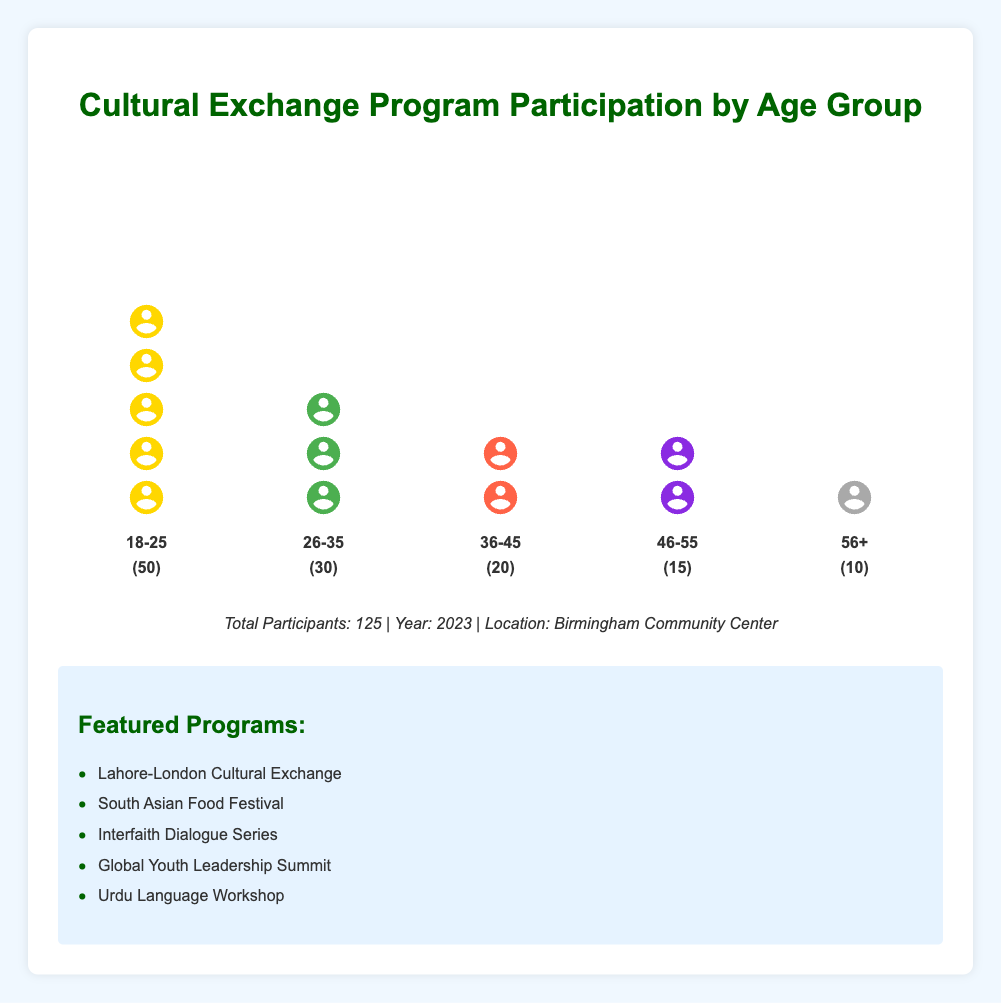What is the age group with the highest participation rate? Look at the isotype plot and identify the column with the most icons. The "18-25" age group has the most icons.
Answer: 18-25 How many total participants are there in the "36-45" age group? The label for the "36-45" age group indicates the number of participants. It shows 20 participants.
Answer: 20 What percentage of total participants does the "56+" age group represent? The "56+" age group has 10 participants. The total number of participants is 125. Calculate the percentage: (10 / 125) * 100 = 8%.
Answer: 8% How many more participants are there in the "18-25" age group than the "26-35" age group? The "18-25" age group has 50 participants, and the "26-35" age group has 30 participants. The difference is 50 - 30 = 20.
Answer: 20 Which age group has the least participation and how many participants are in that group? Look at the isotype plot and find the column with the fewest icons. The "56+" age group has the least participation with 10 participants.
Answer: 56+, 10 What is the total number of participants for the age groups "46-55" and "56+" combined? Add the participants from both age groups: 15 (46-55) + 10 (56+) = 25.
Answer: 25 Among the listed programs, which one might be specifically targeted at the younger age groups? "Global Youth Leadership Summit" is more likely to target younger age groups based on its title.
Answer: Global Youth Leadership Summit Compare the participation rates of the "26-35" age group and the "36-45" age group. Which has more participants? The "26-35" age group has 30 participants, and the "36-45" age group has 20 participants. The "26-35" age group has more participants.
Answer: 26-35 What is the combined percentage representation of the "18-25" and "26-35" age groups out of the total participants? The "18-25" age group has 50 participants, and the "26-35" age group has 30 participants. The total is 80 participants. Percentage: (80 / 125) * 100 = 64%.
Answer: 64% How many participants are there in all age groups except "18-25"? Sum participants from all other age groups: 30 (26-35) + 20 (36-45) + 15 (46-55) + 10 (56+) = 75.
Answer: 75 